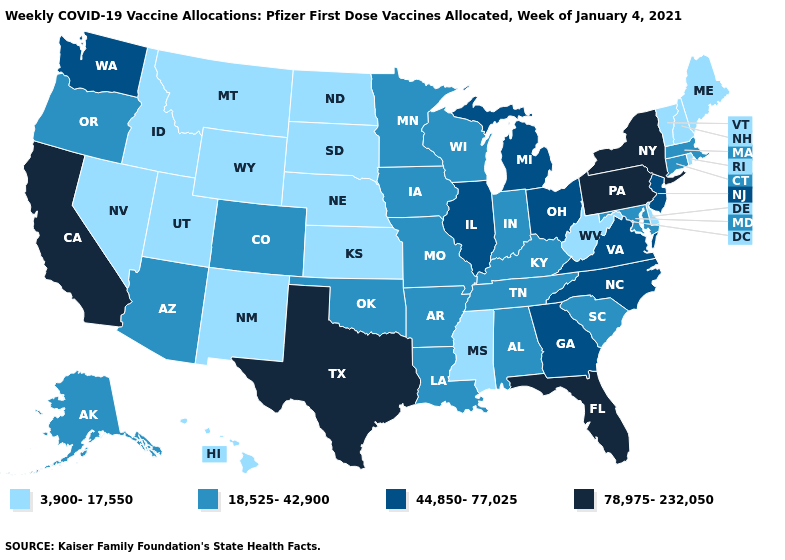Among the states that border Tennessee , which have the lowest value?
Give a very brief answer. Mississippi. How many symbols are there in the legend?
Keep it brief. 4. Name the states that have a value in the range 44,850-77,025?
Give a very brief answer. Georgia, Illinois, Michigan, New Jersey, North Carolina, Ohio, Virginia, Washington. What is the highest value in the USA?
Be succinct. 78,975-232,050. Among the states that border New Hampshire , does Maine have the highest value?
Be succinct. No. Name the states that have a value in the range 18,525-42,900?
Give a very brief answer. Alabama, Alaska, Arizona, Arkansas, Colorado, Connecticut, Indiana, Iowa, Kentucky, Louisiana, Maryland, Massachusetts, Minnesota, Missouri, Oklahoma, Oregon, South Carolina, Tennessee, Wisconsin. What is the highest value in states that border Michigan?
Write a very short answer. 44,850-77,025. What is the highest value in states that border Vermont?
Keep it brief. 78,975-232,050. Does Kentucky have a lower value than New Hampshire?
Write a very short answer. No. Does Virginia have the lowest value in the USA?
Concise answer only. No. Name the states that have a value in the range 3,900-17,550?
Write a very short answer. Delaware, Hawaii, Idaho, Kansas, Maine, Mississippi, Montana, Nebraska, Nevada, New Hampshire, New Mexico, North Dakota, Rhode Island, South Dakota, Utah, Vermont, West Virginia, Wyoming. Which states have the lowest value in the USA?
Answer briefly. Delaware, Hawaii, Idaho, Kansas, Maine, Mississippi, Montana, Nebraska, Nevada, New Hampshire, New Mexico, North Dakota, Rhode Island, South Dakota, Utah, Vermont, West Virginia, Wyoming. Name the states that have a value in the range 78,975-232,050?
Short answer required. California, Florida, New York, Pennsylvania, Texas. Which states have the highest value in the USA?
Write a very short answer. California, Florida, New York, Pennsylvania, Texas. What is the value of New Hampshire?
Short answer required. 3,900-17,550. 